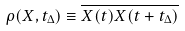<formula> <loc_0><loc_0><loc_500><loc_500>\rho ( X , t _ { \Delta } ) \equiv \overline { X ( t ) X ( t + t _ { \Delta } ) }</formula> 